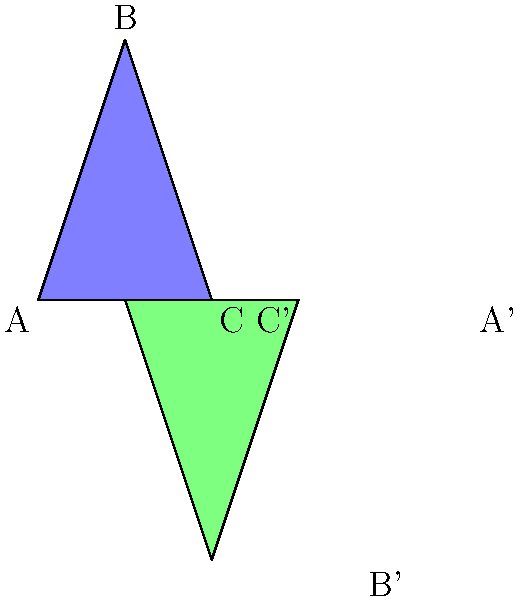The simplified outline of Mount Agung volcano is represented by triangle ABC. If triangle A'B'C' is the result of a transformation applied to triangle ABC, what sequence of transformations was used? To determine the sequence of transformations applied to triangle ABC to obtain triangle A'B'C', let's analyze the changes step-by-step:

1. Orientation: The transformed triangle A'B'C' is upside down compared to ABC. This suggests a rotation of 180°.

2. Position: After the rotation, we notice that the triangle has also moved to the right. This indicates a translation.

3. Size: The transformed triangle appears to be the same size as the original, so there's no scaling involved.

Let's break down the transformations:

a) Rotation: The triangle is rotated 180° around its center. This flips it upside down.
b) Translation: After rotation, the triangle is shifted 3 units to the right.

The order of these transformations matters. In this case, we can see that the rotation was applied first, followed by the translation. If the order were reversed, the final position of the triangle would be different.

Therefore, the sequence of transformations is:
1. Rotate 180° around the center
2. Translate 3 units right
Answer: Rotate 180°, then translate 3 units right 